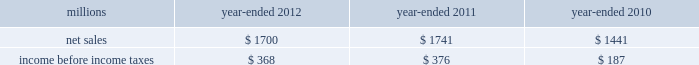74 2012 ppg annual report and form 10-k 25 .
Separation and merger transaction on january , 28 , 2013 , the company completed the previously announced separation of its commodity chemicals business and merger of its wholly-owned subsidiary , eagle spinco inc. , with a subsidiary of georgia gulf corporation in a tax efficient reverse morris trust transaction ( the 201ctransaction 201d ) .
Pursuant to the merger , eagle spinco , the entity holding ppg's former commodity chemicals business , is now a wholly-owned subsidiary of georgia gulf .
The closing of the merger followed the expiration of the related exchange offer and the satisfaction of certain other conditions .
The combined company formed by uniting georgia gulf with ppg's former commodity chemicals business is named axiall corporation ( 201caxiall 201d ) .
Ppg holds no ownership interest in axiall .
Ppg received the necessary ruling from the internal revenue service and as a result this transaction was generally tax free to ppg and its shareholders .
Under the terms of the exchange offer , 35249104 shares of eagle spinco common stock were available for distribution in exchange for shares of ppg common stock accepted in the offer .
Following the merger , each share of eagle spinco common stock automatically converted into the right to receive one share of axiall corporation common stock .
Accordingly , ppg shareholders who tendered their shares of ppg common stock as part of this offer received 3.2562 shares of axiall common stock for each share of ppg common stock accepted for exchange .
Ppg was able to accept the maximum of 10825227 shares of ppg common stock for exchange in the offer , and thereby , reduced its outstanding shares by approximately 7% ( 7 % ) .
Under the terms of the transaction , ppg received $ 900 million of cash and 35.2 million shares of axiall common stock ( market value of $ 1.8 billion on january 25 , 2013 ) which was distributed to ppg shareholders by the exchange offer as described above .
The cash consideration is subject to customary post-closing adjustment , including a working capital adjustment .
In the transaction , ppg transferred environmental remediation liabilities , defined benefit pension plan assets and liabilities and other post-employment benefit liabilities related to the commodity chemicals business to axiall .
Ppg will report a gain on the transaction reflecting the excess of the sum of the cash proceeds received and the cost ( closing stock price on january 25 , 2013 ) of the ppg shares tendered and accepted in the exchange for the 35.2 million shares of axiall common stock over the net book value of the net assets of ppg's former commodity chemicals business .
The transaction will also result in a net partial settlement loss associated with the spin out and termination of defined benefit pension liabilities and the transfer of other post-retirement benefit liabilities under the terms of the transaction .
During 2012 , the company incurred $ 21 million of pretax expense , primarily for professional services , related to the transaction .
Additional transaction-related expenses will be incurred in 2013 .
Ppg will report the results of its commodity chemicals business for january 2013 and a net gain on the transaction as results from discontinued operations when it reports its results for the quarter ending march 31 , 2013 .
In the ppg results for prior periods , presented for comparative purposes beginning with the first quarter 2013 , the results of its former commodity chemicals business will be reclassified from continuing operations and presented as the results from discontinued operations .
The net sales and income before income taxes of the commodity chemicals business that will be reclassified and reported as discontinued operations are presented in the table below for the years ended december 31 , 2012 , 2011 and 2010: .
Income before income taxes for the year ended december 31 , 2012 , 2011 and 2010 is $ 4 million lower , $ 6 million higher and $ 2 million lower , respectively , than segment earnings for the ppg commodity chemicals segment reported for these periods .
These differences are due to the inclusion of certain gains , losses and expenses associated with the chlor-alkali and derivatives business that were not reported in the ppg commodity chemicals segment earnings in accordance with the accounting guidance on segment reporting .
Table of contents notes to the consolidated financial statements .
What is the cumulative three year return on net sales for discontinued operations? 
Computations: divide(table_sum(income before income taxes, none), table_sum(net sales, none))
Answer: 0.1907. 74 2012 ppg annual report and form 10-k 25 .
Separation and merger transaction on january , 28 , 2013 , the company completed the previously announced separation of its commodity chemicals business and merger of its wholly-owned subsidiary , eagle spinco inc. , with a subsidiary of georgia gulf corporation in a tax efficient reverse morris trust transaction ( the 201ctransaction 201d ) .
Pursuant to the merger , eagle spinco , the entity holding ppg's former commodity chemicals business , is now a wholly-owned subsidiary of georgia gulf .
The closing of the merger followed the expiration of the related exchange offer and the satisfaction of certain other conditions .
The combined company formed by uniting georgia gulf with ppg's former commodity chemicals business is named axiall corporation ( 201caxiall 201d ) .
Ppg holds no ownership interest in axiall .
Ppg received the necessary ruling from the internal revenue service and as a result this transaction was generally tax free to ppg and its shareholders .
Under the terms of the exchange offer , 35249104 shares of eagle spinco common stock were available for distribution in exchange for shares of ppg common stock accepted in the offer .
Following the merger , each share of eagle spinco common stock automatically converted into the right to receive one share of axiall corporation common stock .
Accordingly , ppg shareholders who tendered their shares of ppg common stock as part of this offer received 3.2562 shares of axiall common stock for each share of ppg common stock accepted for exchange .
Ppg was able to accept the maximum of 10825227 shares of ppg common stock for exchange in the offer , and thereby , reduced its outstanding shares by approximately 7% ( 7 % ) .
Under the terms of the transaction , ppg received $ 900 million of cash and 35.2 million shares of axiall common stock ( market value of $ 1.8 billion on january 25 , 2013 ) which was distributed to ppg shareholders by the exchange offer as described above .
The cash consideration is subject to customary post-closing adjustment , including a working capital adjustment .
In the transaction , ppg transferred environmental remediation liabilities , defined benefit pension plan assets and liabilities and other post-employment benefit liabilities related to the commodity chemicals business to axiall .
Ppg will report a gain on the transaction reflecting the excess of the sum of the cash proceeds received and the cost ( closing stock price on january 25 , 2013 ) of the ppg shares tendered and accepted in the exchange for the 35.2 million shares of axiall common stock over the net book value of the net assets of ppg's former commodity chemicals business .
The transaction will also result in a net partial settlement loss associated with the spin out and termination of defined benefit pension liabilities and the transfer of other post-retirement benefit liabilities under the terms of the transaction .
During 2012 , the company incurred $ 21 million of pretax expense , primarily for professional services , related to the transaction .
Additional transaction-related expenses will be incurred in 2013 .
Ppg will report the results of its commodity chemicals business for january 2013 and a net gain on the transaction as results from discontinued operations when it reports its results for the quarter ending march 31 , 2013 .
In the ppg results for prior periods , presented for comparative purposes beginning with the first quarter 2013 , the results of its former commodity chemicals business will be reclassified from continuing operations and presented as the results from discontinued operations .
The net sales and income before income taxes of the commodity chemicals business that will be reclassified and reported as discontinued operations are presented in the table below for the years ended december 31 , 2012 , 2011 and 2010: .
Income before income taxes for the year ended december 31 , 2012 , 2011 and 2010 is $ 4 million lower , $ 6 million higher and $ 2 million lower , respectively , than segment earnings for the ppg commodity chemicals segment reported for these periods .
These differences are due to the inclusion of certain gains , losses and expenses associated with the chlor-alkali and derivatives business that were not reported in the ppg commodity chemicals segment earnings in accordance with the accounting guidance on segment reporting .
Table of contents notes to the consolidated financial statements .
What was the percentage change in net sales of the commodity chemicals business that will be reclassified and reported as discontinued operations from 2010 to 2011? 
Computations: ((1741 - 1441) / 1441)
Answer: 0.20819. 